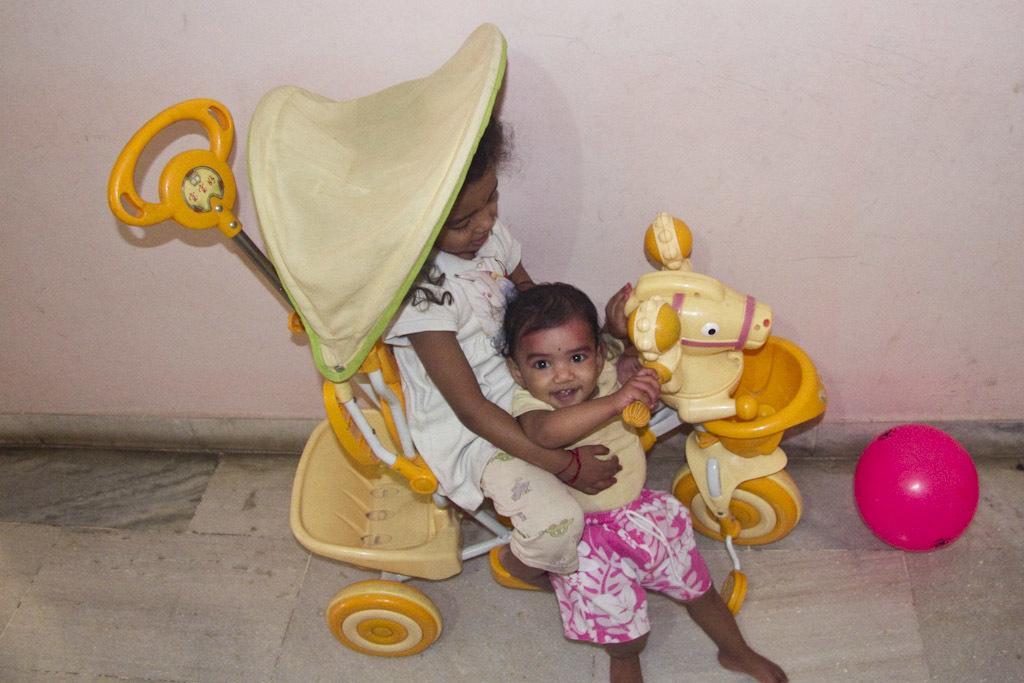In one or two sentences, can you explain what this image depicts? This is an inside view. Here I can see a girl sitting on a toy vehicle and holding a baby in the hands. The baby is smiling and looking at the picture. This vehicle is facing towards the right side. On the right side there is a pink color ball on the floor. In the background there is a wall. 